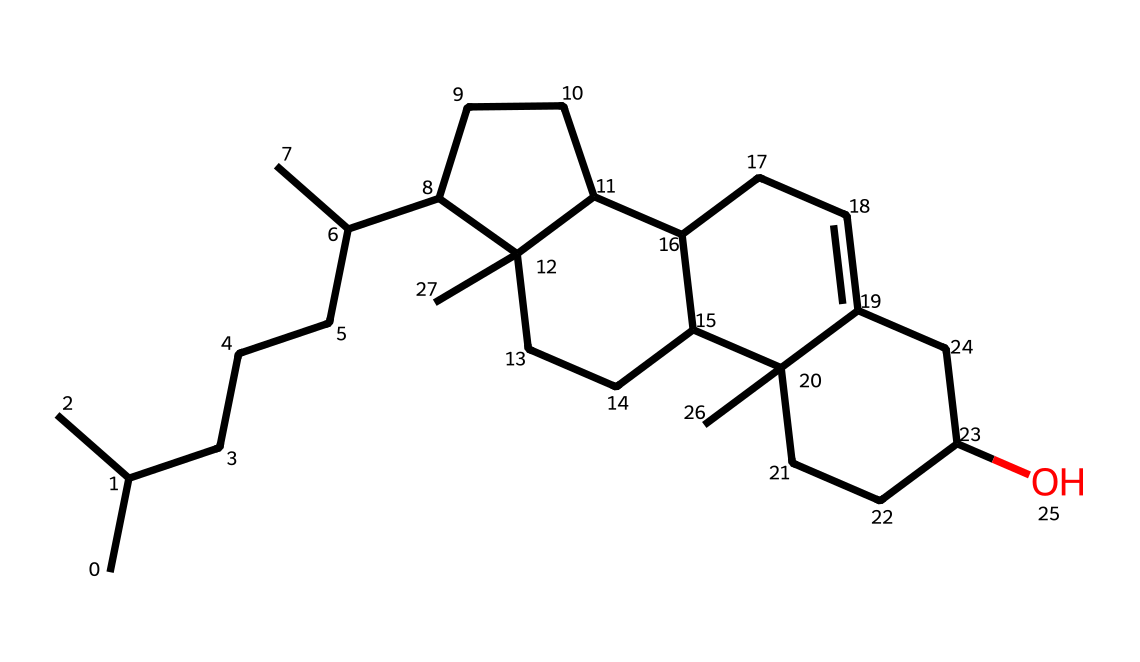What is the molecular formula of this cholesterol structure? To determine the molecular formula, count the number of carbon (C), hydrogen (H), and oxygen (O) atoms in the SMILES representation. In this case, cholesterol has 27 carbon atoms, 46 hydrogen atoms, and 1 oxygen atom. Therefore, the molecular formula is C27H46O.
Answer: C27H46O How many rings are present in this cholesterol structure? By analyzing the molecular structure represented by the SMILES, we can identify the number of fused ring systems. Cholesterol contains a total of four fused hydrocarbon rings.
Answer: four What type of lipid is cholesterol classified as? Cholesterol is classified as a sterol, which is a subgroup of steroids. It is characterized by its four-ring core structure and hydroxyl group, which fits the definition of sterols.
Answer: sterol What is the role of cholesterol in cell membranes? Cholesterol plays a critical role in maintaining membrane fluidity and stability. It modulates the fluidity of the lipid bilayer, allowing for proper membrane functionality.
Answer: membrane fluidity What effect does cholesterol have on membrane permeability? Cholesterol decreases membrane permeability by tightly packing the phospholipid molecules and reducing the water permeability of the membrane. This is crucial for maintaining cellular integrity.
Answer: decreases permeability How does cholesterol affect the fluidity of membrane lipids? Cholesterol acts as a fluidity buffer; at high temperatures, it prevents excessive fluidity, while at low temperatures, it hinders close packing of lipids, thus preventing solidification.
Answer: fluidity buffer 